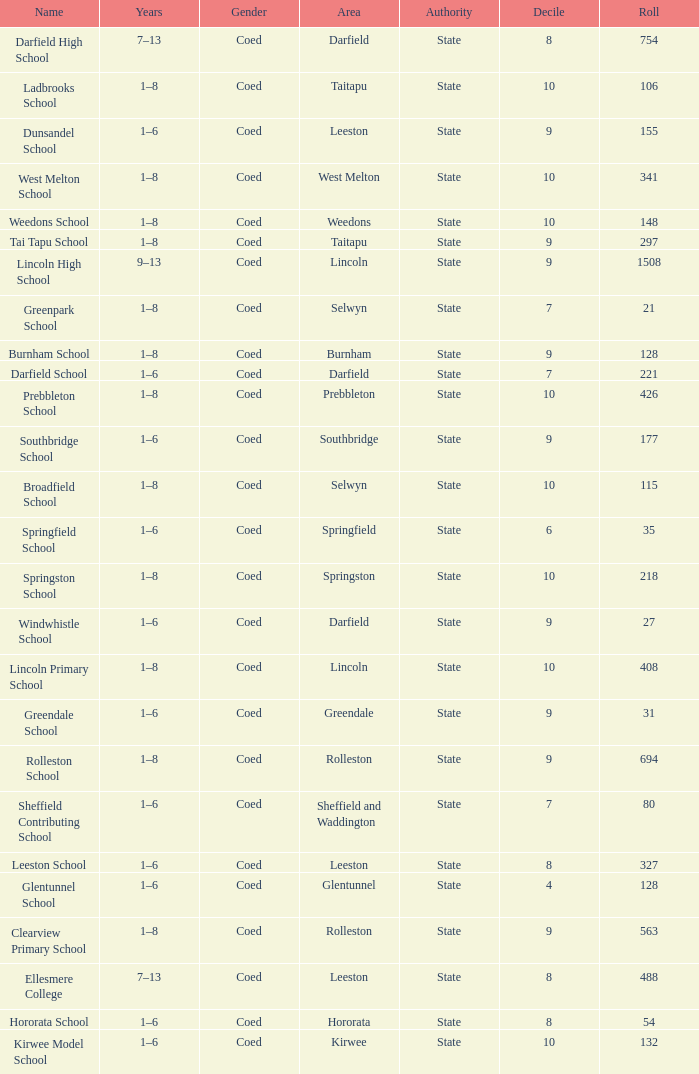Which name has a Roll larger than 297, and Years of 7–13? Darfield High School, Ellesmere College. Could you help me parse every detail presented in this table? {'header': ['Name', 'Years', 'Gender', 'Area', 'Authority', 'Decile', 'Roll'], 'rows': [['Darfield High School', '7–13', 'Coed', 'Darfield', 'State', '8', '754'], ['Ladbrooks School', '1–8', 'Coed', 'Taitapu', 'State', '10', '106'], ['Dunsandel School', '1–6', 'Coed', 'Leeston', 'State', '9', '155'], ['West Melton School', '1–8', 'Coed', 'West Melton', 'State', '10', '341'], ['Weedons School', '1–8', 'Coed', 'Weedons', 'State', '10', '148'], ['Tai Tapu School', '1–8', 'Coed', 'Taitapu', 'State', '9', '297'], ['Lincoln High School', '9–13', 'Coed', 'Lincoln', 'State', '9', '1508'], ['Greenpark School', '1–8', 'Coed', 'Selwyn', 'State', '7', '21'], ['Burnham School', '1–8', 'Coed', 'Burnham', 'State', '9', '128'], ['Darfield School', '1–6', 'Coed', 'Darfield', 'State', '7', '221'], ['Prebbleton School', '1–8', 'Coed', 'Prebbleton', 'State', '10', '426'], ['Southbridge School', '1–6', 'Coed', 'Southbridge', 'State', '9', '177'], ['Broadfield School', '1–8', 'Coed', 'Selwyn', 'State', '10', '115'], ['Springfield School', '1–6', 'Coed', 'Springfield', 'State', '6', '35'], ['Springston School', '1–8', 'Coed', 'Springston', 'State', '10', '218'], ['Windwhistle School', '1–6', 'Coed', 'Darfield', 'State', '9', '27'], ['Lincoln Primary School', '1–8', 'Coed', 'Lincoln', 'State', '10', '408'], ['Greendale School', '1–6', 'Coed', 'Greendale', 'State', '9', '31'], ['Rolleston School', '1–8', 'Coed', 'Rolleston', 'State', '9', '694'], ['Sheffield Contributing School', '1–6', 'Coed', 'Sheffield and Waddington', 'State', '7', '80'], ['Leeston School', '1–6', 'Coed', 'Leeston', 'State', '8', '327'], ['Glentunnel School', '1–6', 'Coed', 'Glentunnel', 'State', '4', '128'], ['Clearview Primary School', '1–8', 'Coed', 'Rolleston', 'State', '9', '563'], ['Ellesmere College', '7–13', 'Coed', 'Leeston', 'State', '8', '488'], ['Hororata School', '1–6', 'Coed', 'Hororata', 'State', '8', '54'], ['Kirwee Model School', '1–6', 'Coed', 'Kirwee', 'State', '10', '132']]} 